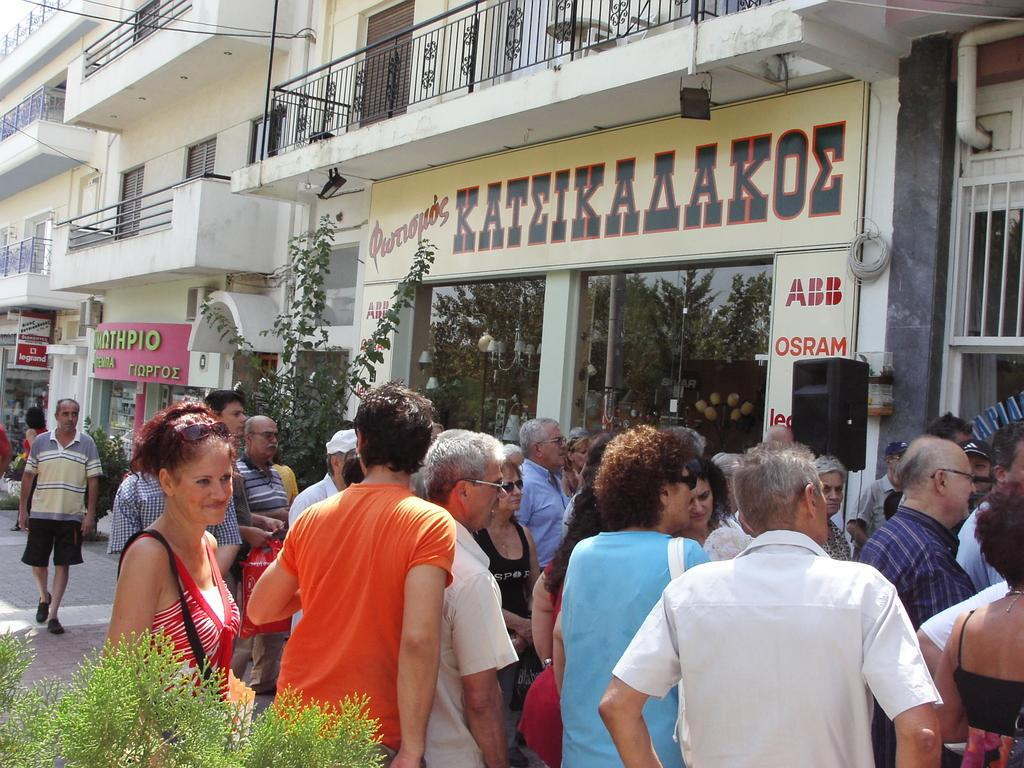What are the people in the image doing? The people in the image are standing and walking on a path. What can be seen in the background of the image? There are buildings and trees in the background of the image. Where is the tree located in the image? There is a tree at the bottom left side of the image. How many apples are hanging from the tree in the image? There are no apples visible on the tree in the image. What type of ring can be seen on the finger of the person walking on the path? There is no ring visible on any person's finger in the image. 